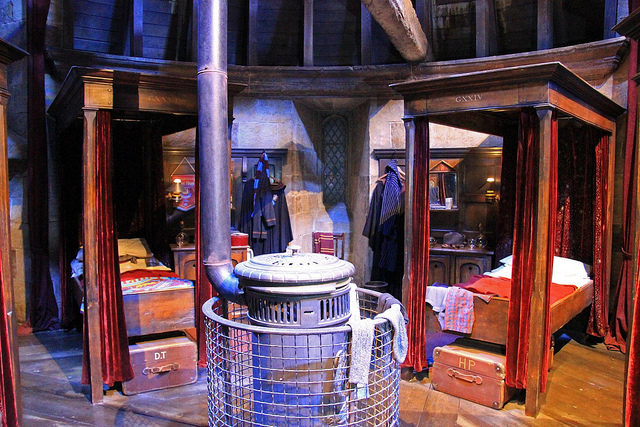Can you name some of the distinct props visible in this image from the Harry Potter series? In the image, you can see several props that characterize the Harry Potter universe. There's a cauldron, likely used for potions, trunks including one marked with 'HP' presumably for Harry Potter, and the wooden beds that suit the Gryffindor dormitory style. 